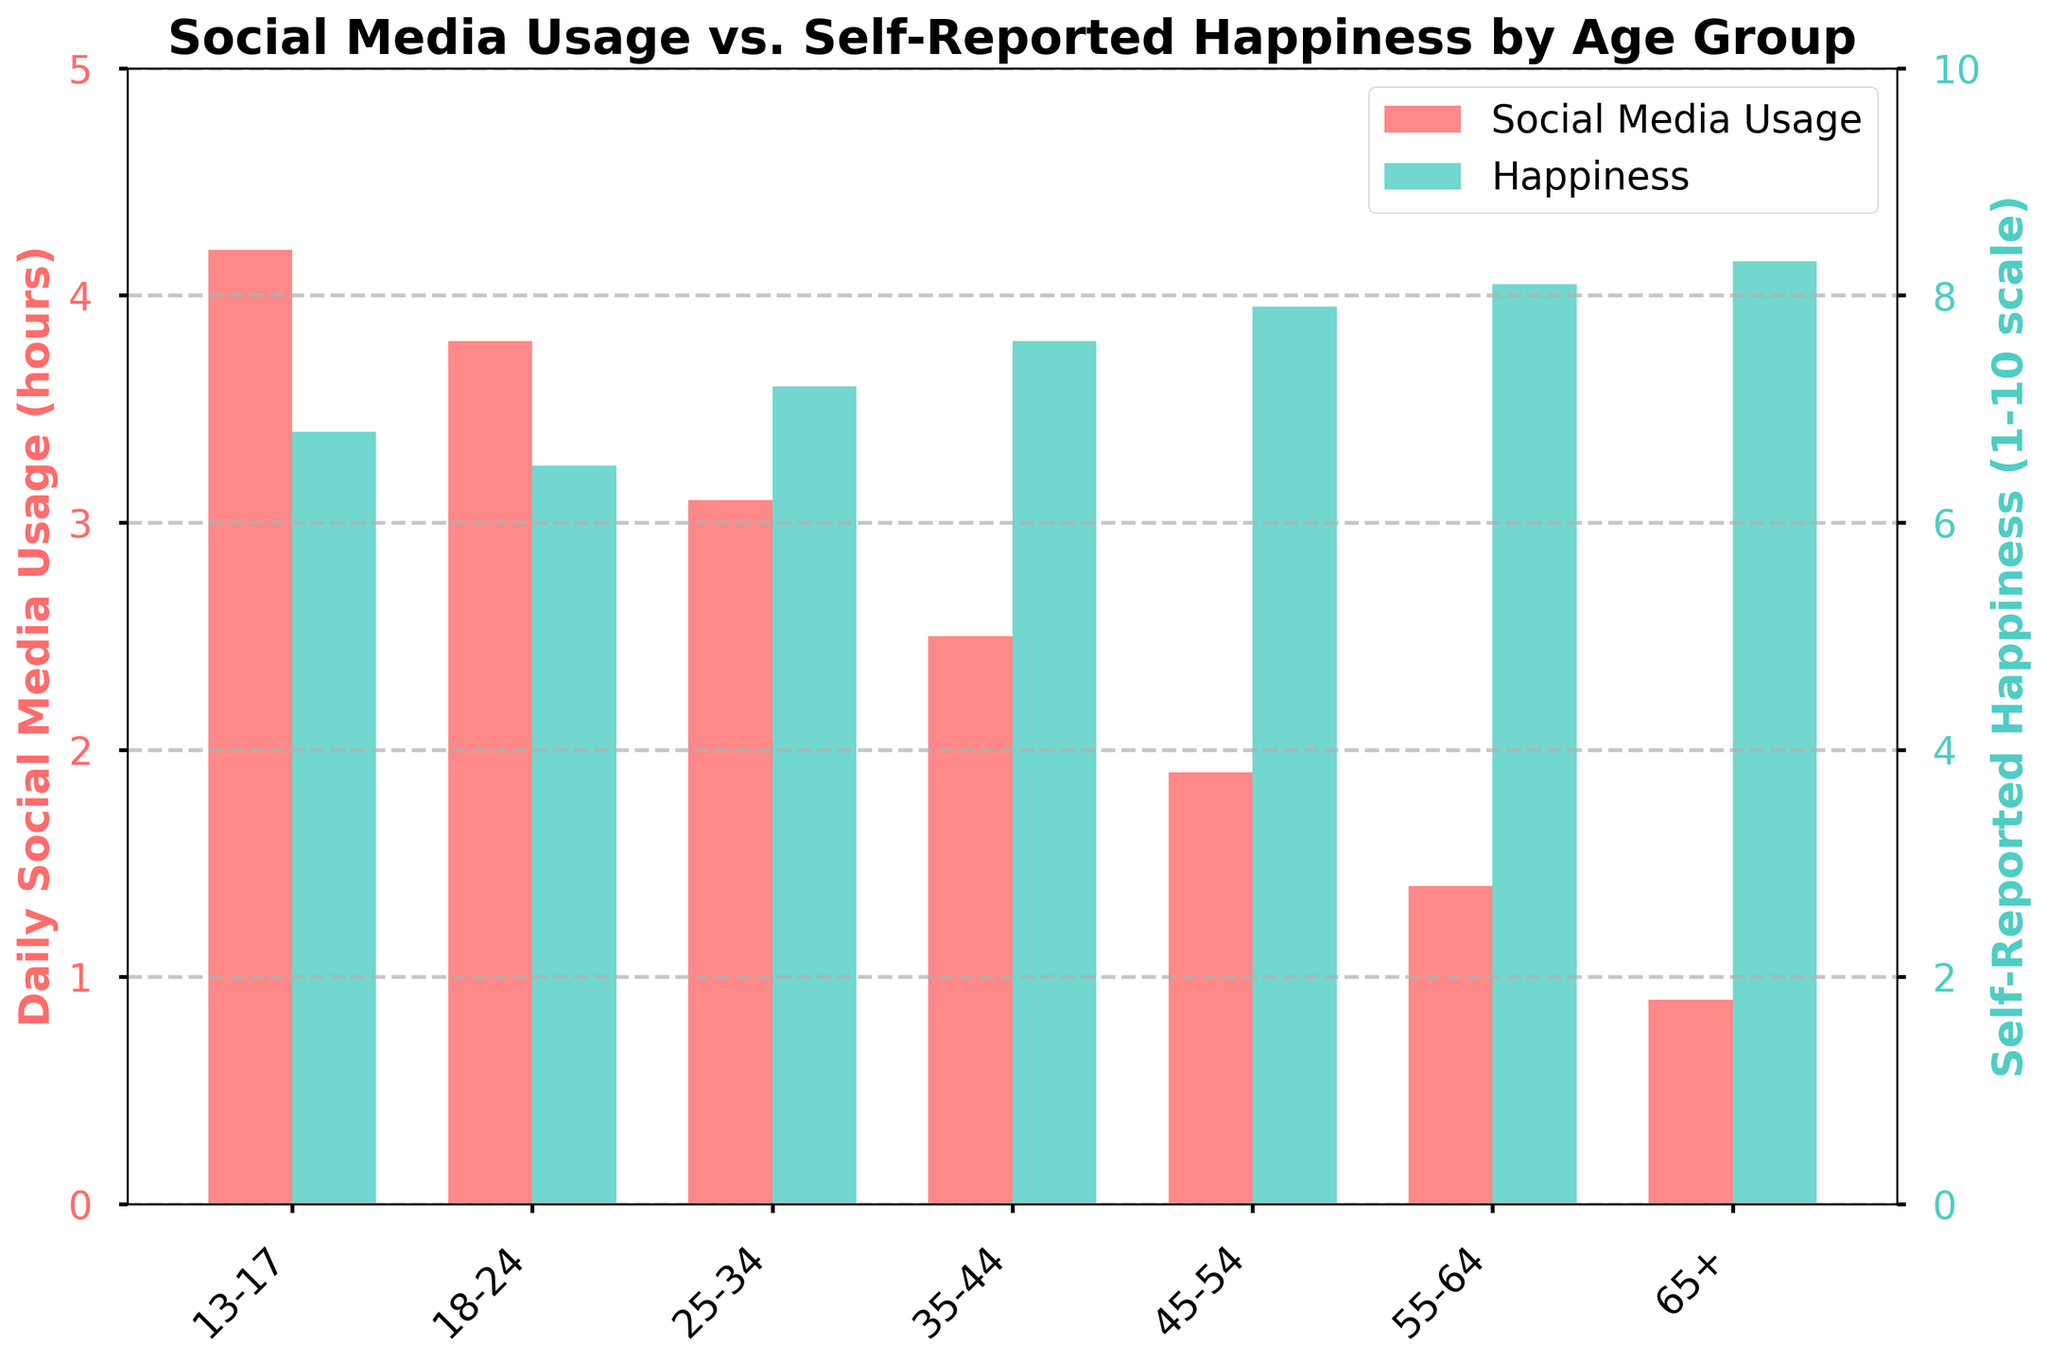What is the daily social media usage for the 18-24 age group? Find the bar corresponding to the 18-24 age group and read off the value on the left y-axis (Daily Social Media Usage).
Answer: 3.8 hours Which age group reports the highest level of happiness? Look at the green bars representing self-reported happiness and identify the tallest bar.
Answer: 65+ Which age group has the lowest self-reported happiness? Locate the shortest green bar and read off the corresponding age group.
Answer: 18-24 How does the social media usage trend change as age increases? Observe the trend of the red bars representing daily social media usage across age groups, noting whether the bars increase or decrease in height.
Answer: Decreases What is the difference in social media usage between the youngest (13-17) and oldest (65+) age groups? Subtract the daily social media usage of the oldest age group (0.9 hours) from the usage of the youngest age group (4.2 hours).
Answer: 3.3 hours How does self-reported happiness change from the 25-34 age group to the 55-64 age group? Compare the heights of the green bars for the 25-34 and 55-64 age groups. Subtract the 25-34 value (7.2) from the 55-64 value (8.1).
Answer: Increases by 0.9 Which age group uses social media more, 35-44 or 45-54? Compare the heights of the red bars for the 35-44 and 45-54 age groups.
Answer: 35-44 What is the average self-reported happiness across all age groups? Sum the happiness values for all age groups (6.8 + 6.5 + 7.2 + 7.6 + 7.9 + 8.1 + 8.3) and divide by the number of age groups (7).
Answer: 7.49 Which age group shows the most significant difference between social media usage and self-reported happiness? Calculate the difference between the heights of the red and green bars for each age group and identify the greatest value.
Answer: 13-17 Is there a visual relationship between social media usage and happiness levels? Look for a pattern or correlation between the heights of the red and green bars across the age groups, noting if they generally increase or decrease together or inversely.
Answer: Inverse relationship 